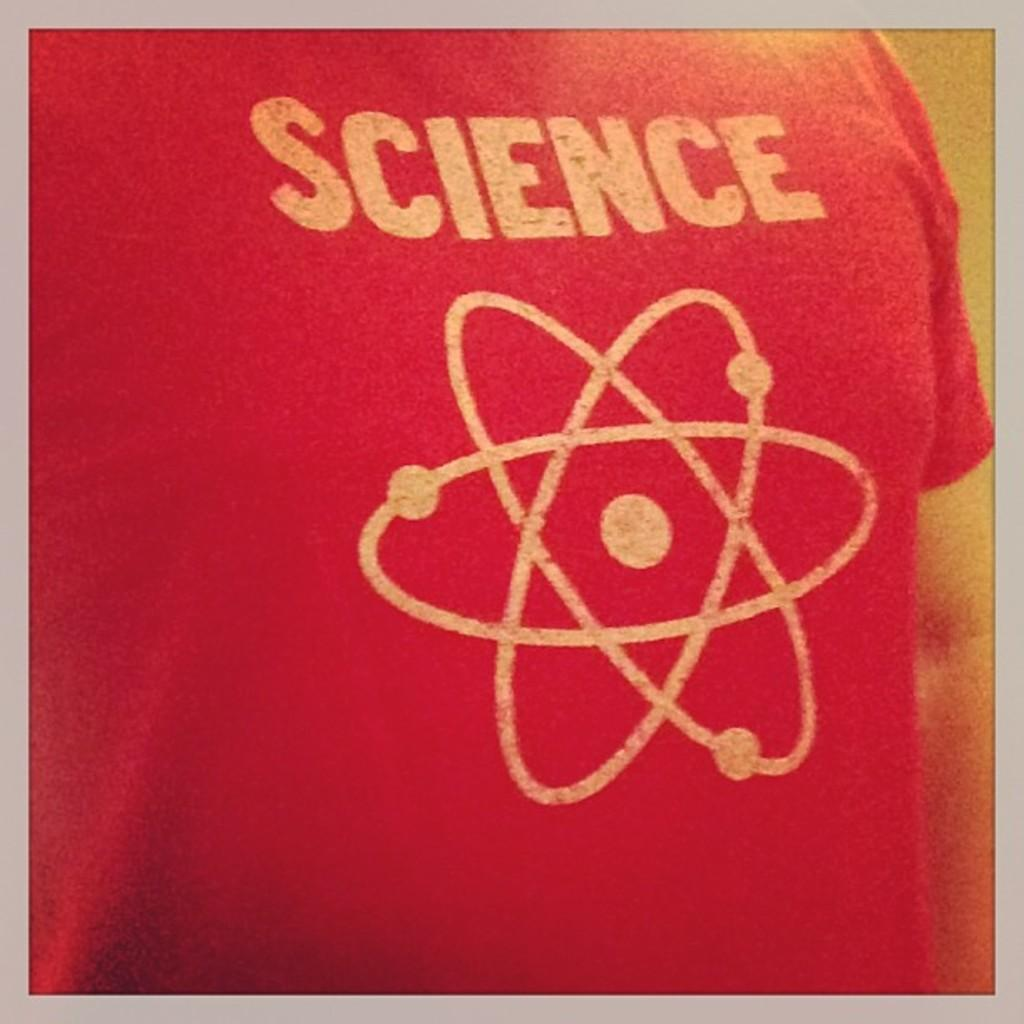<image>
Give a short and clear explanation of the subsequent image. Red shirt that has the word SCIENCE in white letters. 